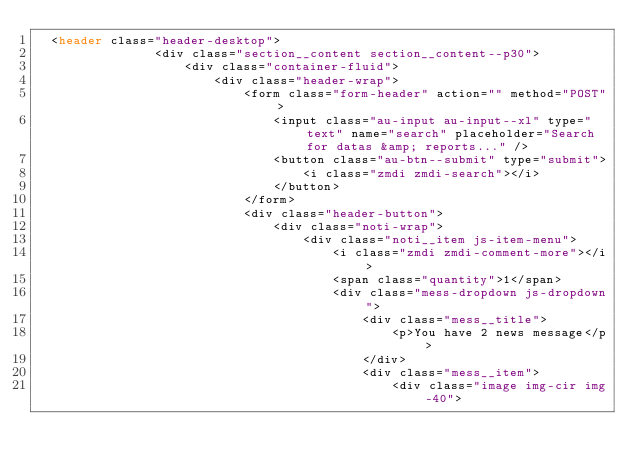<code> <loc_0><loc_0><loc_500><loc_500><_PHP_>  <header class="header-desktop">
                <div class="section__content section__content--p30">
                    <div class="container-fluid">
                        <div class="header-wrap">
                            <form class="form-header" action="" method="POST">
                                <input class="au-input au-input--xl" type="text" name="search" placeholder="Search for datas &amp; reports..." />
                                <button class="au-btn--submit" type="submit">
                                    <i class="zmdi zmdi-search"></i>
                                </button>
                            </form>
                            <div class="header-button">
                                <div class="noti-wrap">
                                    <div class="noti__item js-item-menu">
                                        <i class="zmdi zmdi-comment-more"></i>
                                        <span class="quantity">1</span>
                                        <div class="mess-dropdown js-dropdown">
                                            <div class="mess__title">
                                                <p>You have 2 news message</p>
                                            </div>
                                            <div class="mess__item">
                                                <div class="image img-cir img-40"></code> 